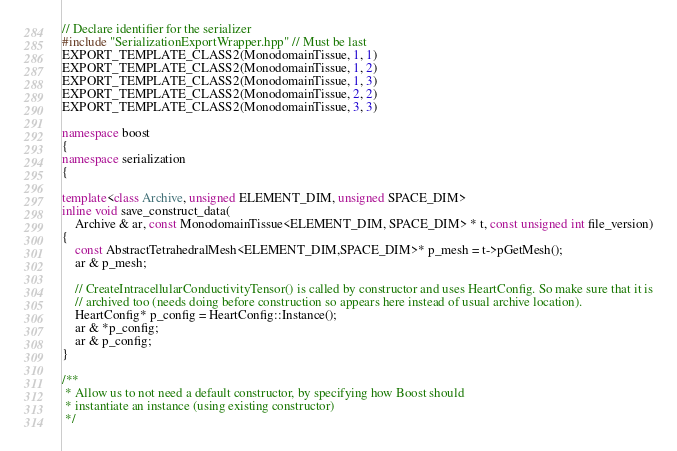<code> <loc_0><loc_0><loc_500><loc_500><_C++_>

// Declare identifier for the serializer
#include "SerializationExportWrapper.hpp" // Must be last
EXPORT_TEMPLATE_CLASS2(MonodomainTissue, 1, 1)
EXPORT_TEMPLATE_CLASS2(MonodomainTissue, 1, 2)
EXPORT_TEMPLATE_CLASS2(MonodomainTissue, 1, 3)
EXPORT_TEMPLATE_CLASS2(MonodomainTissue, 2, 2)
EXPORT_TEMPLATE_CLASS2(MonodomainTissue, 3, 3)

namespace boost
{
namespace serialization
{

template<class Archive, unsigned ELEMENT_DIM, unsigned SPACE_DIM>
inline void save_construct_data(
    Archive & ar, const MonodomainTissue<ELEMENT_DIM, SPACE_DIM> * t, const unsigned int file_version)
{
    const AbstractTetrahedralMesh<ELEMENT_DIM,SPACE_DIM>* p_mesh = t->pGetMesh();
    ar & p_mesh;

    // CreateIntracellularConductivityTensor() is called by constructor and uses HeartConfig. So make sure that it is
    // archived too (needs doing before construction so appears here instead of usual archive location).
    HeartConfig* p_config = HeartConfig::Instance();
    ar & *p_config;
    ar & p_config;
}

/**
 * Allow us to not need a default constructor, by specifying how Boost should
 * instantiate an instance (using existing constructor)
 */</code> 